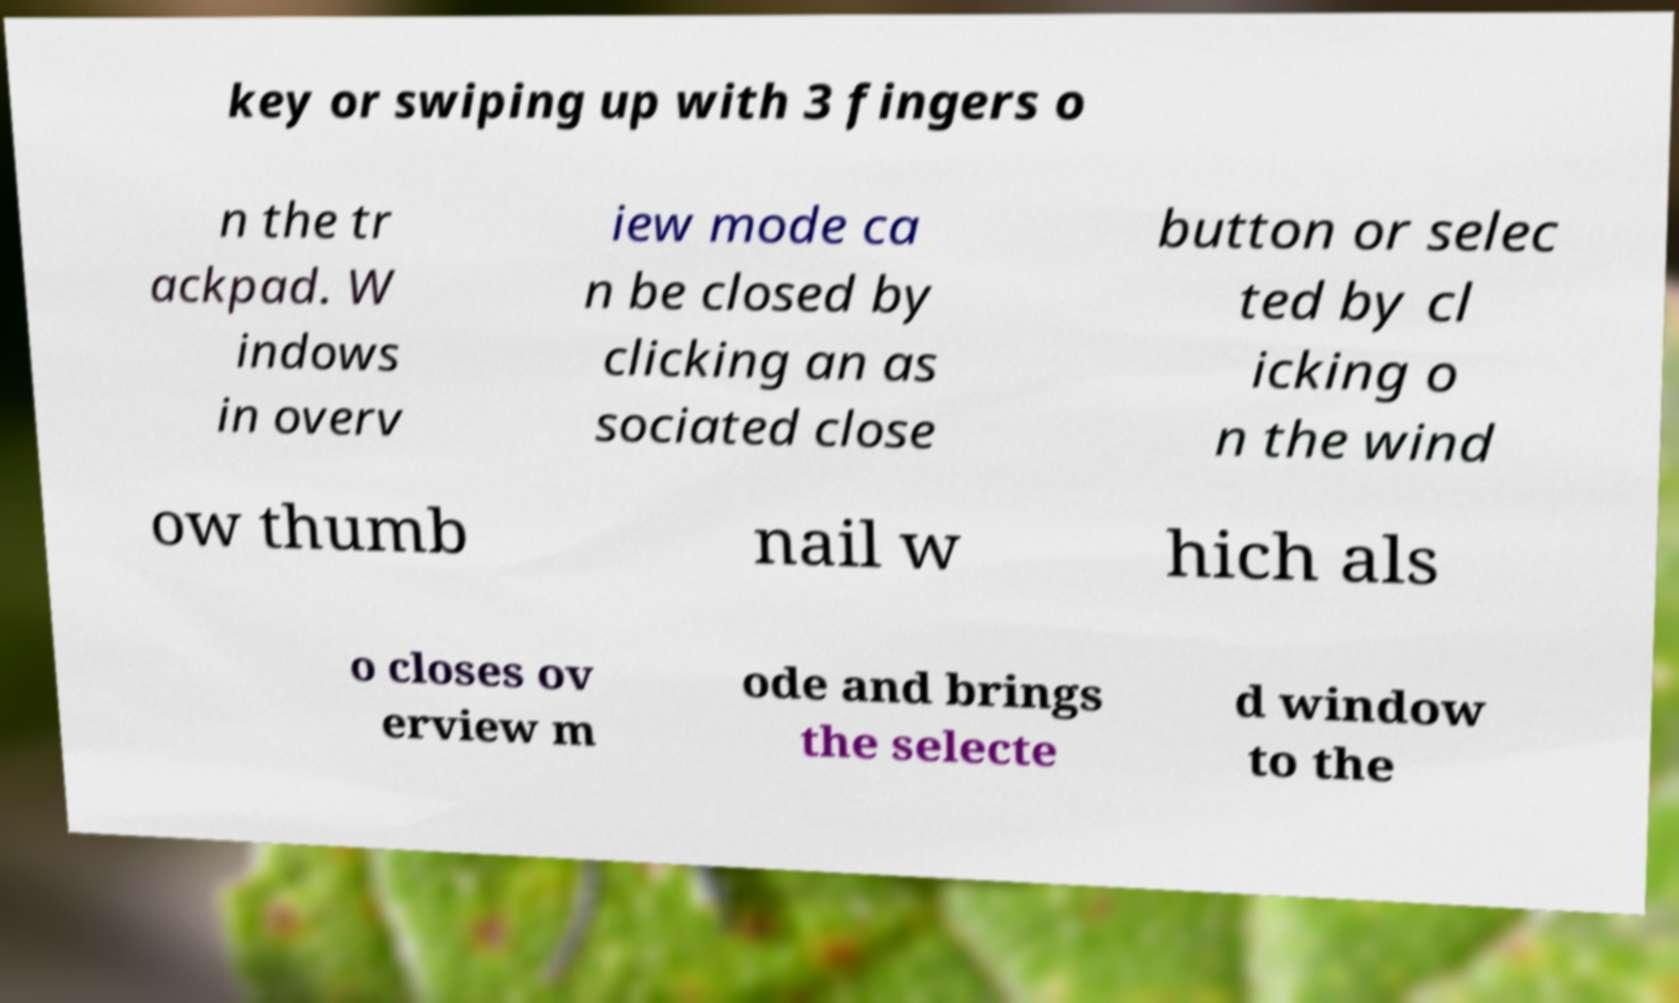For documentation purposes, I need the text within this image transcribed. Could you provide that? key or swiping up with 3 fingers o n the tr ackpad. W indows in overv iew mode ca n be closed by clicking an as sociated close button or selec ted by cl icking o n the wind ow thumb nail w hich als o closes ov erview m ode and brings the selecte d window to the 